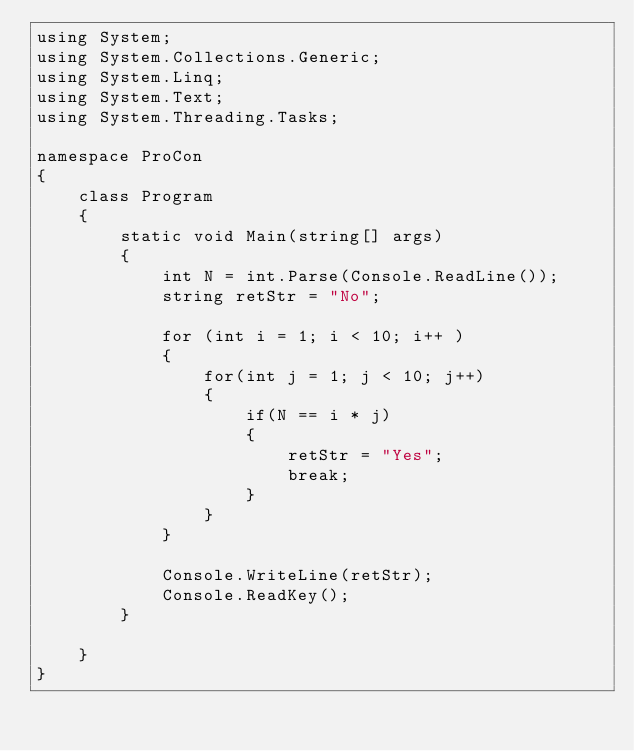<code> <loc_0><loc_0><loc_500><loc_500><_C#_>using System;
using System.Collections.Generic;
using System.Linq;
using System.Text;
using System.Threading.Tasks;

namespace ProCon
{
    class Program
    {
        static void Main(string[] args)
        {
            int N = int.Parse(Console.ReadLine());
            string retStr = "No";

            for (int i = 1; i < 10; i++ )
            {
                for(int j = 1; j < 10; j++)
                {
                    if(N == i * j)
                    {
                        retStr = "Yes";
                        break;
                    }
                }
            }

            Console.WriteLine(retStr);
            Console.ReadKey();
        }

    }
}
</code> 